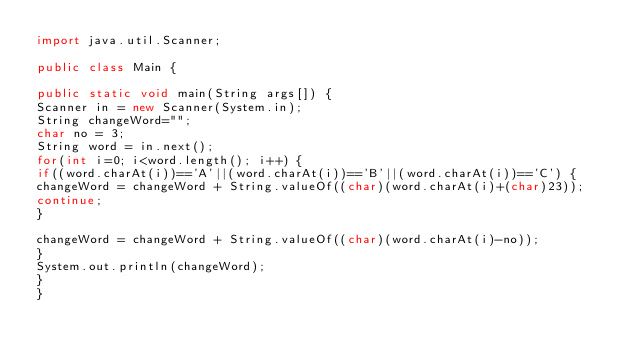<code> <loc_0><loc_0><loc_500><loc_500><_Java_>import java.util.Scanner;

public class Main {

public static void main(String args[]) {
Scanner in = new Scanner(System.in);
String changeWord="";
char no = 3;
String word = in.next();
for(int i=0; i<word.length(); i++) {
if((word.charAt(i))=='A'||(word.charAt(i))=='B'||(word.charAt(i))=='C') {
changeWord = changeWord + String.valueOf((char)(word.charAt(i)+(char)23));
continue;
}

changeWord = changeWord + String.valueOf((char)(word.charAt(i)-no));
}
System.out.println(changeWord);
}
}</code> 